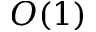Convert formula to latex. <formula><loc_0><loc_0><loc_500><loc_500>O ( 1 )</formula> 